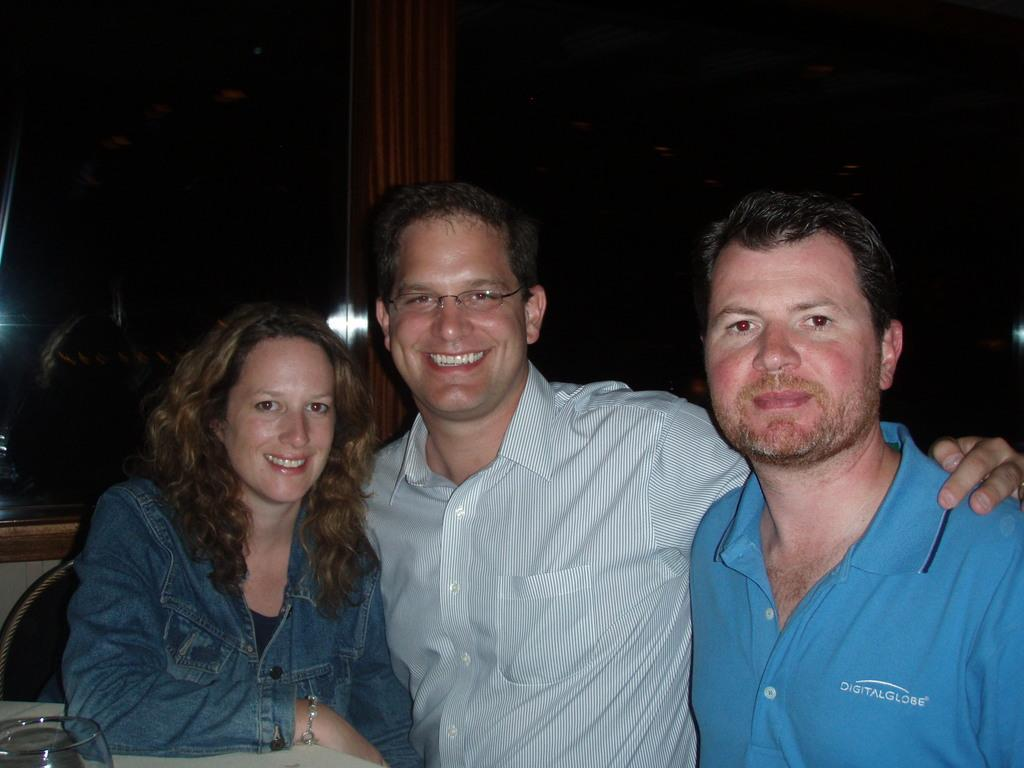How many people are present in the image? There are three people in the image: a man, a woman, and another man on the right side. What are the expressions of the people in the image? Both the man and the woman are smiling in the image. What can be seen on the left side of the image? There is a glass on a table on the left side of the image. What type of architectural feature is visible in the image? There is a glass window visible in the image. What type of mint is growing on the window sill in the image? There is no mint visible in the image; only a glass window is present. What do the people in the image believe about the bottle on the table? There is no bottle present in the image, so it is not possible to determine what the people believe about it. 